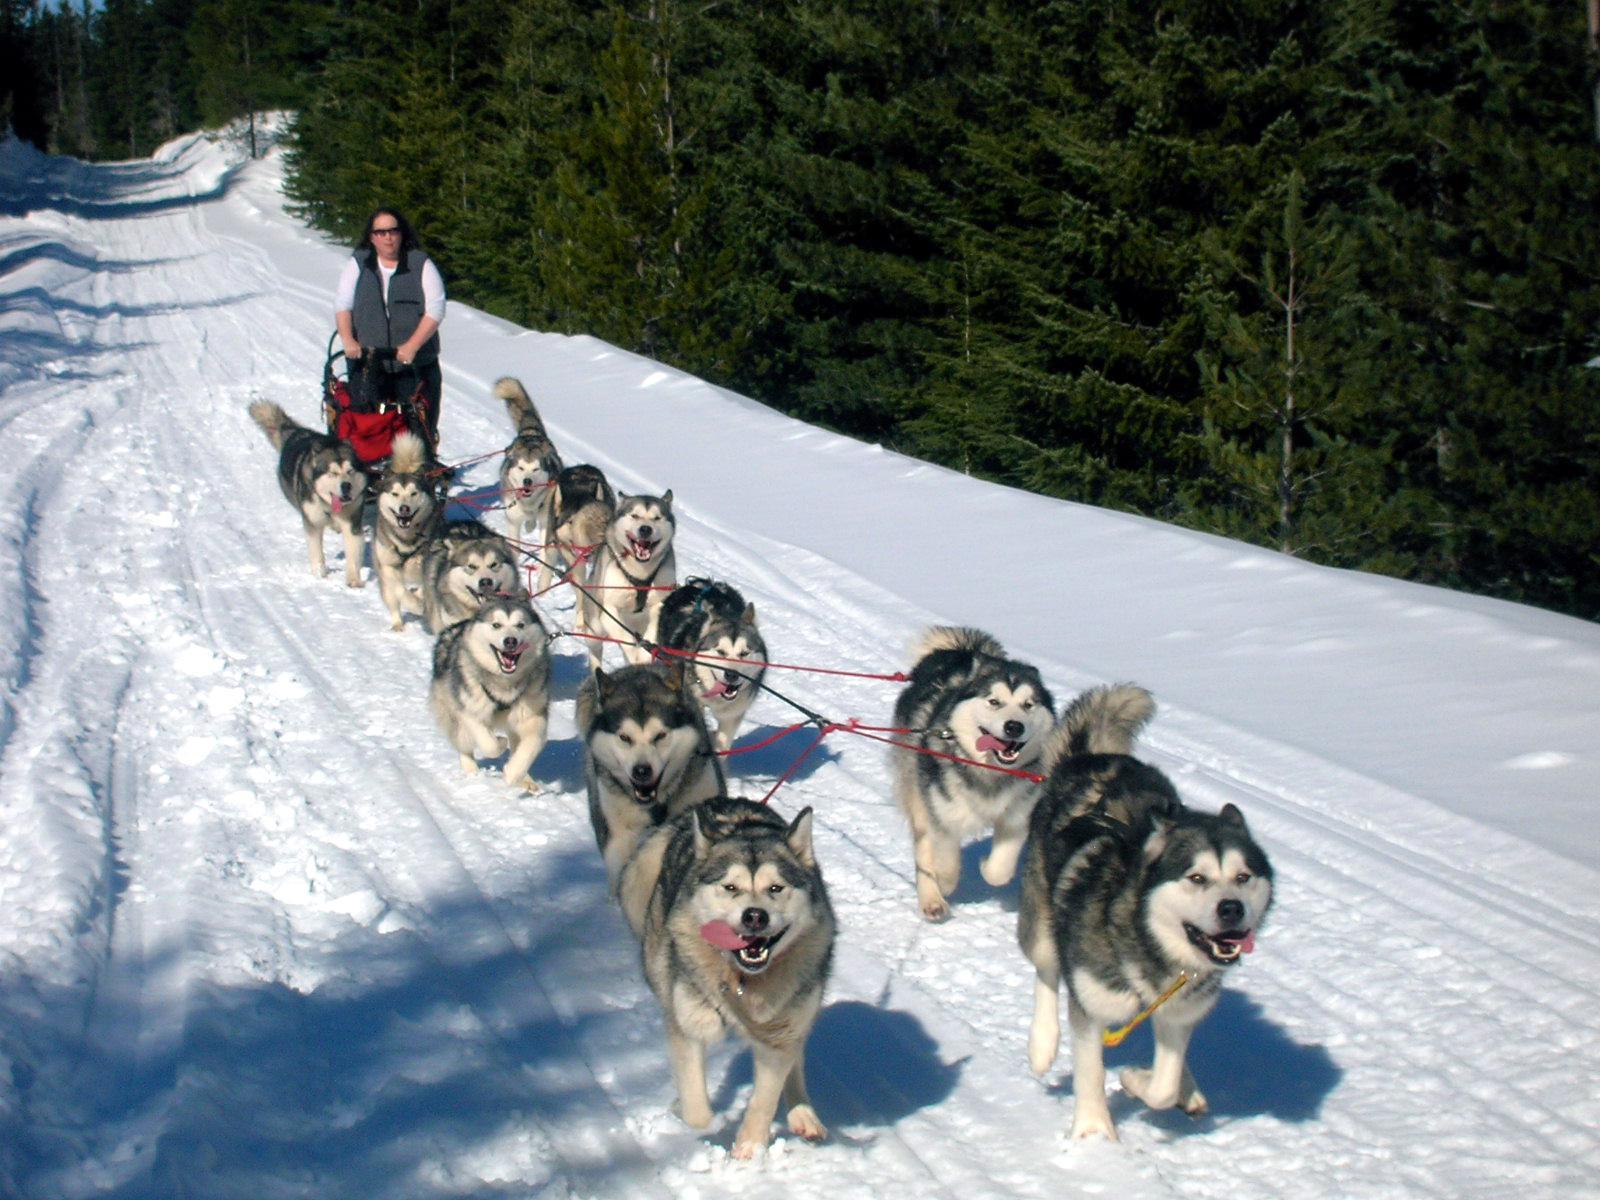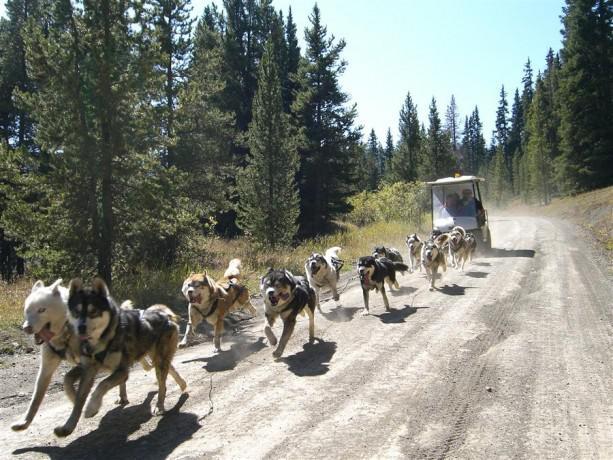The first image is the image on the left, the second image is the image on the right. Assess this claim about the two images: "The dog sled teams in the left and right images move forward over snow at some angle [instead of away from the camera] but are not heading toward each other.". Correct or not? Answer yes or no. No. The first image is the image on the left, the second image is the image on the right. Examine the images to the left and right. Is the description "In the left image, all dogs have blue harnesses." accurate? Answer yes or no. No. 